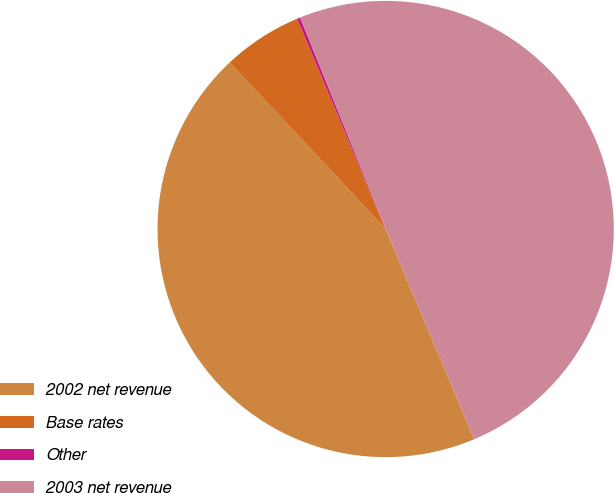Convert chart to OTSL. <chart><loc_0><loc_0><loc_500><loc_500><pie_chart><fcel>2002 net revenue<fcel>Base rates<fcel>Other<fcel>2003 net revenue<nl><fcel>44.36%<fcel>5.64%<fcel>0.22%<fcel>49.78%<nl></chart> 